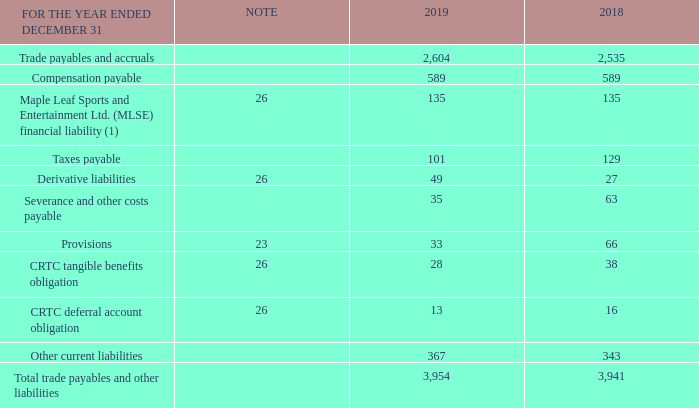Note 20 Trade payables and other liabilities
(1) Represents BCE’s obligation to repurchase the BCE Master Trust Fund’s (Master Trust Fund) 9% interest in MLSE at a price not less than an agreed minimum price should the Master Trust Fund exercise its put option. The obligation to repurchase is marked to market each reporting period and the gain or loss is recorded in Other expense in the income statements.
What does the table show? Trade payables and other liabilities. What is the Trade payables and accruals for 2019? 2,604. What are the years that the context makes reference to? 2018, 2019. What is the total amount of taxes payable in 2018 and 2019? 101+129
Answer: 230. What is the change in the amount of provisions in 2019? 33-66
Answer: -33. What is the percentage change in the amount of CRTC tangible benefits obligation in 2019?
Answer scale should be: percent. (28-38)/38
Answer: -26.32. 